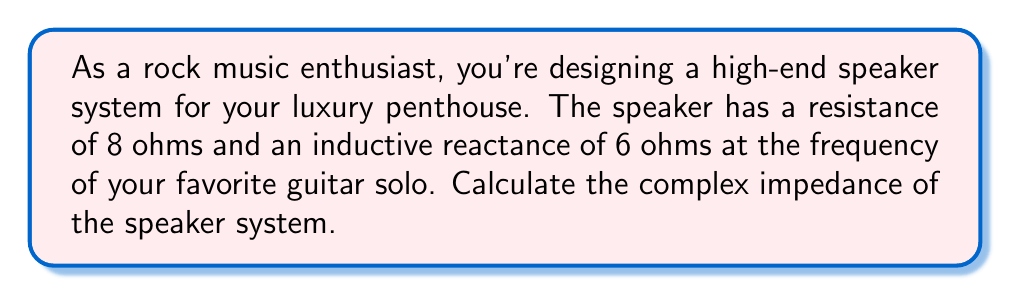Show me your answer to this math problem. To determine the complex impedance of the speaker system, we need to combine the resistance and inductive reactance using complex numbers.

1. Resistance (R) is represented by the real part: 8 ohms
2. Inductive reactance (X_L) is represented by the imaginary part: 6 ohms

The complex impedance (Z) is given by the formula:

$$ Z = R + jX_L $$

Where j is the imaginary unit (√-1).

Substituting the values:

$$ Z = 8 + j6 $$

This can also be expressed in polar form:

$$ Z = |Z| \angle \theta $$

Where |Z| is the magnitude and θ is the phase angle.

To find the magnitude:
$$ |Z| = \sqrt{R^2 + X_L^2} = \sqrt{8^2 + 6^2} = \sqrt{64 + 36} = \sqrt{100} = 10 \text{ ohms} $$

To find the phase angle:
$$ \theta = \tan^{-1}\left(\frac{X_L}{R}\right) = \tan^{-1}\left(\frac{6}{8}\right) \approx 36.87° $$

Therefore, the complex impedance in polar form is:

$$ Z = 10 \angle 36.87° \text{ ohms} $$
Answer: $8 + j6 \text{ ohms}$ or $10 \angle 36.87° \text{ ohms}$ 